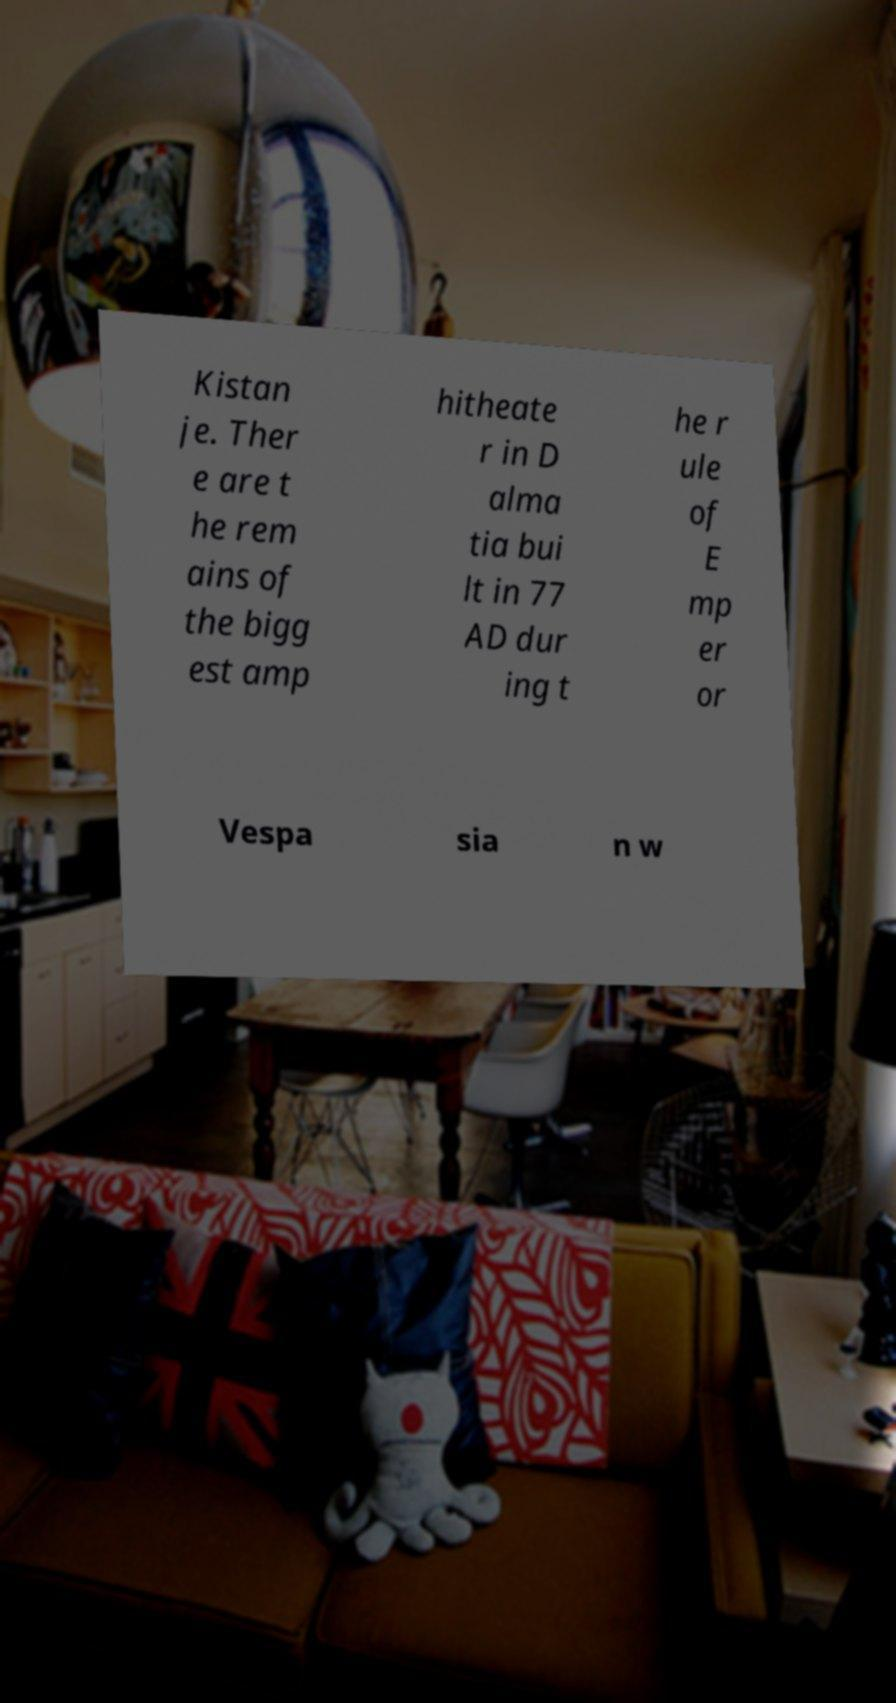There's text embedded in this image that I need extracted. Can you transcribe it verbatim? Kistan je. Ther e are t he rem ains of the bigg est amp hitheate r in D alma tia bui lt in 77 AD dur ing t he r ule of E mp er or Vespa sia n w 